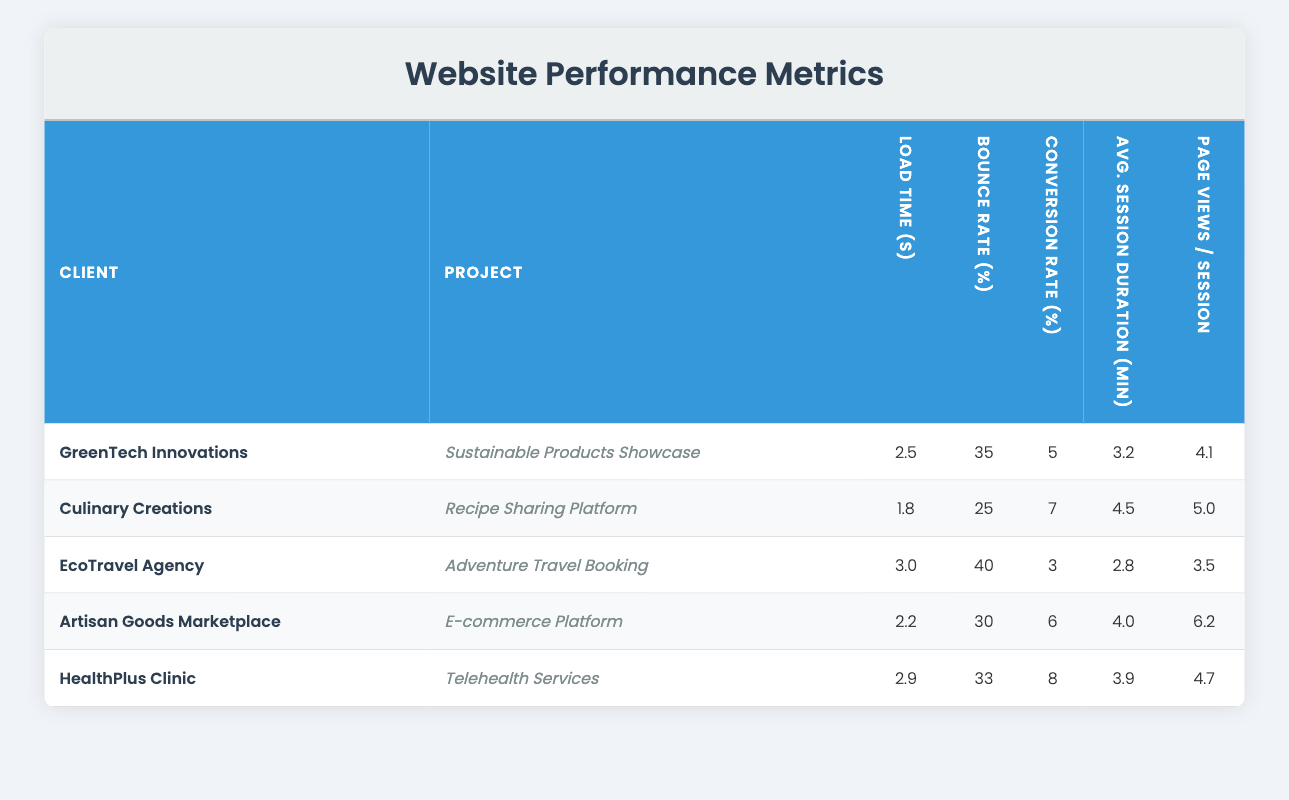What is the load time of the Culinary Creations project? The table indicates that the load time for the Culinary Creations project, which is the Recipe Sharing Platform, is listed under the "Load Time (s)" column as 1.8 seconds.
Answer: 1.8 seconds Which project has the highest conversion rate? Upon reviewing the conversion rates for all projects, the HealthPlus Clinic project has the highest conversion rate listed at 8 percent under the "Conversion Rate (%)" column.
Answer: HealthPlus Clinic project What is the average session duration for EcoTravel Agency? The average session duration for EcoTravel Agency is stated in the table under the column "Avg. Session Duration (min)" with a value of 2.8 minutes.
Answer: 2.8 minutes How many projects have a bounce rate greater than 30 percent? Looking at the bounce rates in the table, the projects with a bounce rate greater than 30 percent are EcoTravel Agency (40%), GreenTech Innovations (35%), and Artisan Goods Marketplace (30%). Since Artisan Goods Marketplace exactly equals 30%, we only consider the first two. Thus, there are two projects with a bounce rate greater than 30 percent.
Answer: 2 Calculate the average load time across all projects. To find the average load time, we sum all the load times: (2.5 + 1.8 + 3.0 + 2.2 + 2.9) = 12.4 seconds. Then, we divide by the number of projects, which is 5. Therefore, the average load time is 12.4 / 5 = 2.48 seconds.
Answer: 2.48 seconds Is the Artisan Goods Marketplace’s page views per session greater than 5? The table lists Artisan Goods Marketplace's page views per session at 6.2, which exceeds 5. Therefore, it is true that the page views per session for this project are greater than 5.
Answer: Yes Which client has the highest bounce rate and what is that rate? By examining the bounce rates listed in the column "Bounce Rate (%)", EcoTravel Agency has the highest bounce rate at 40 percent.
Answer: EcoTravel Agency, 40 percent What is the total number of page views per session for all projects combined? To find this, we add up the page views per session for all projects: (4.1 + 5.0 + 3.5 + 6.2 + 4.7) = 23.5. Therefore, the total number of page views per session across all projects is 23.5.
Answer: 23.5 What is the difference in conversion rates between Culinary Creations and EcoTravel Agency? The conversion rate for Culinary Creations is 7 percent and for EcoTravel Agency it is 3 percent. The difference is calculated as 7 - 3 = 4 percent.
Answer: 4 percent 